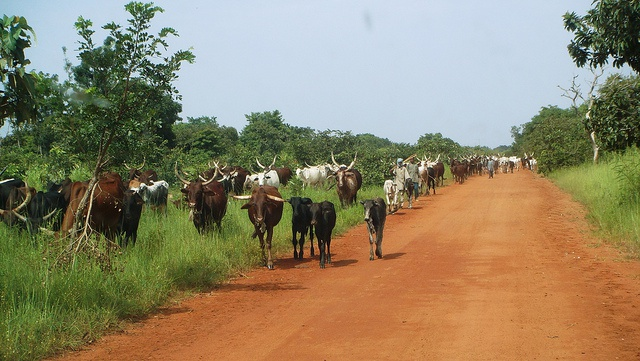Describe the objects in this image and their specific colors. I can see cow in lightblue, black, darkgreen, maroon, and olive tones, cow in lightblue, black, maroon, olive, and brown tones, cow in lightblue, black, maroon, darkgreen, and gray tones, cow in lightblue, black, olive, and maroon tones, and cow in lightblue, black, darkgreen, maroon, and brown tones in this image. 